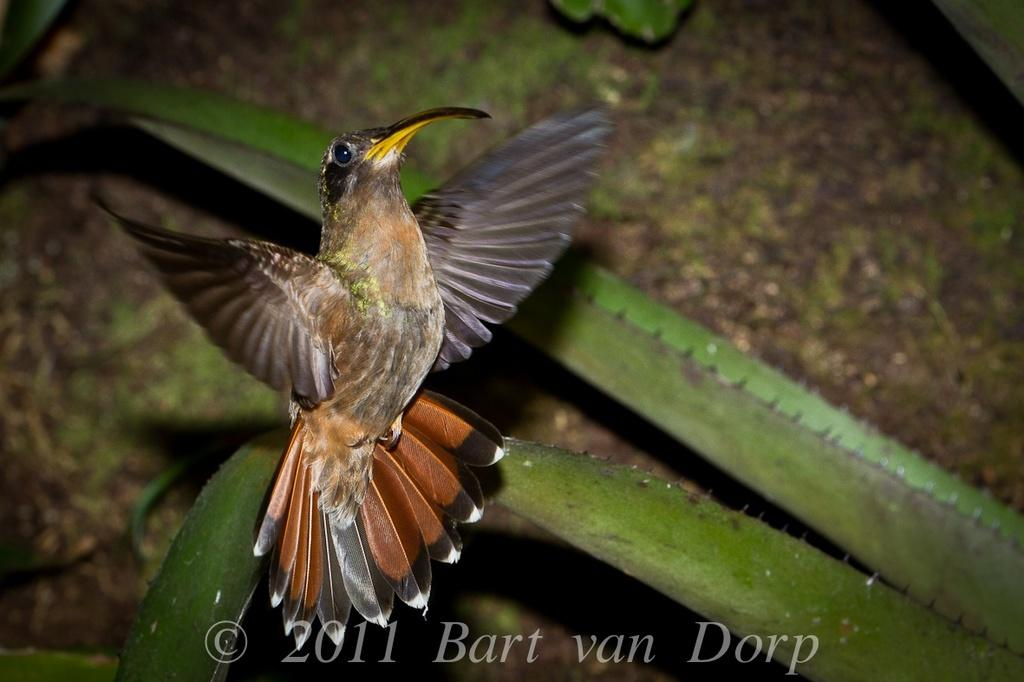What type of animal can be seen in the image? There is a bird in the image. What other living organism is present in the image? There is a plant in the image. What is the surface on which the bird and plant are situated? There is ground visible in the image. Is there any text present in the image? Yes, there is some text at the bottom of the image. What flavor of ice cream is being served on the plate in the image? There is no plate or ice cream present in the image; it features a bird and a plant on the ground. What type of government is depicted in the image? There is no government depicted in the image; it features a bird, a plant, and some text on the ground. 